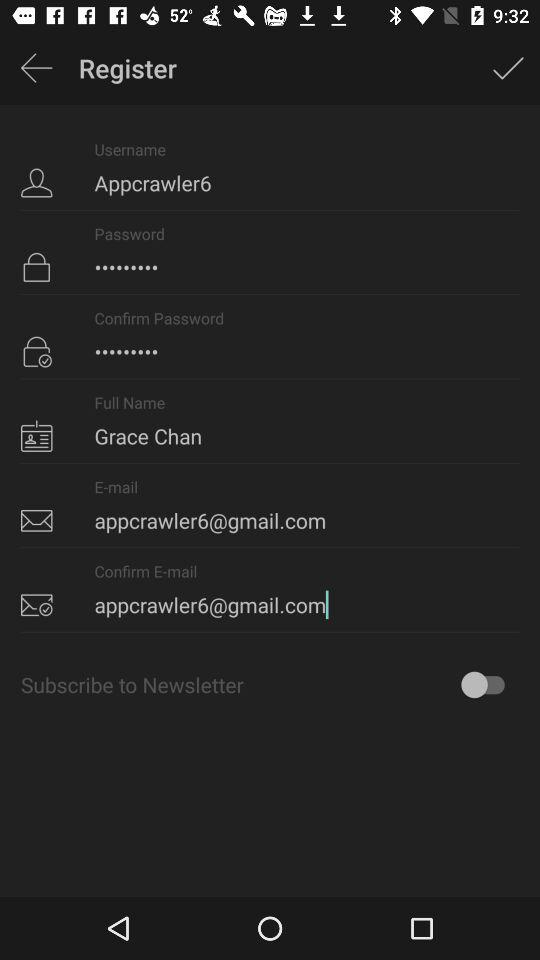What is the username? The username is "Appcrawler6". 